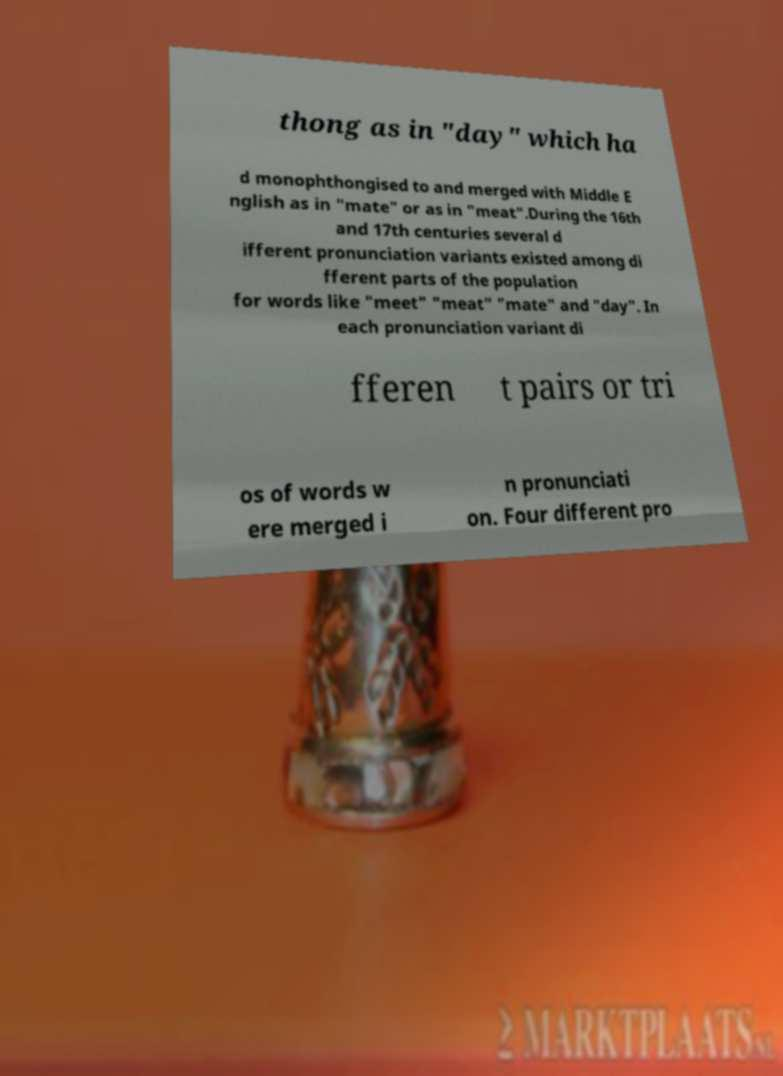For documentation purposes, I need the text within this image transcribed. Could you provide that? thong as in "day" which ha d monophthongised to and merged with Middle E nglish as in "mate" or as in "meat".During the 16th and 17th centuries several d ifferent pronunciation variants existed among di fferent parts of the population for words like "meet" "meat" "mate" and "day". In each pronunciation variant di fferen t pairs or tri os of words w ere merged i n pronunciati on. Four different pro 